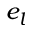Convert formula to latex. <formula><loc_0><loc_0><loc_500><loc_500>e _ { l }</formula> 